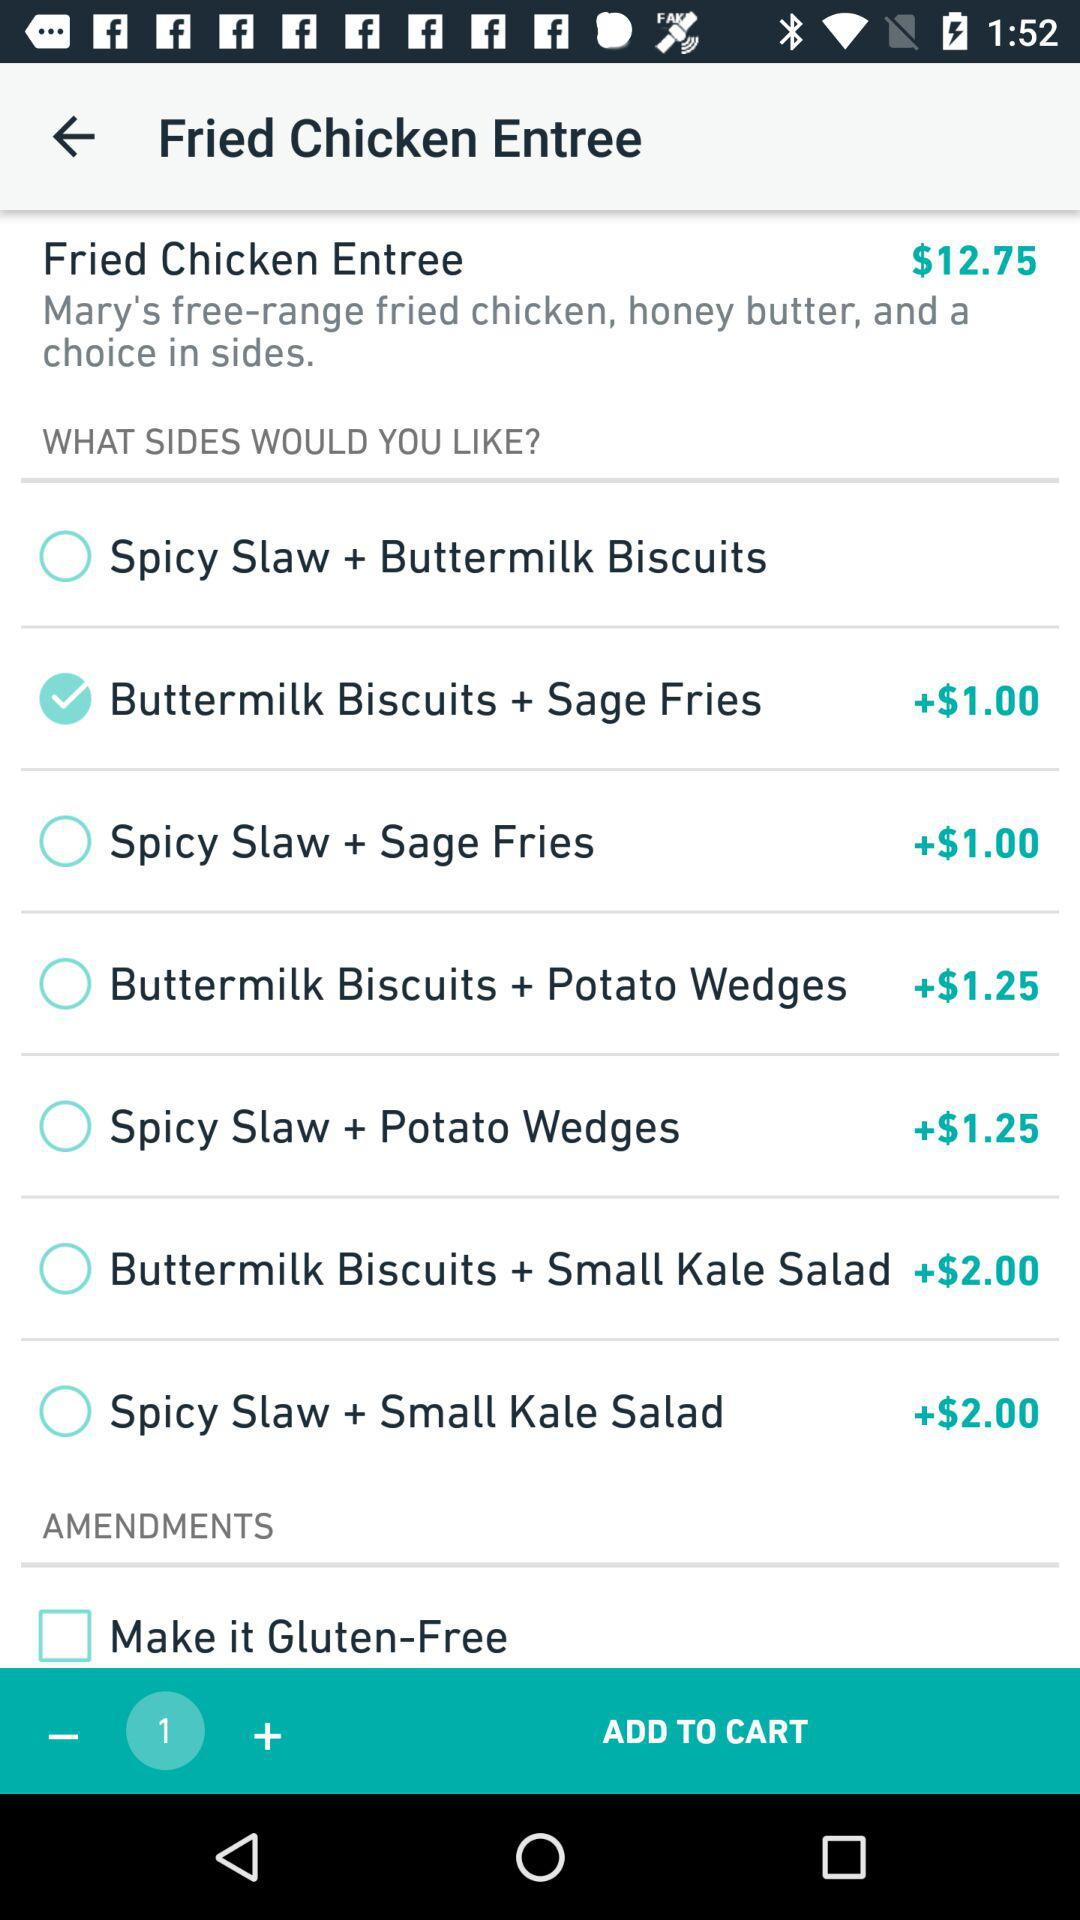How many items are there to be added to the cart? There is 1 item to be added to the cart. 